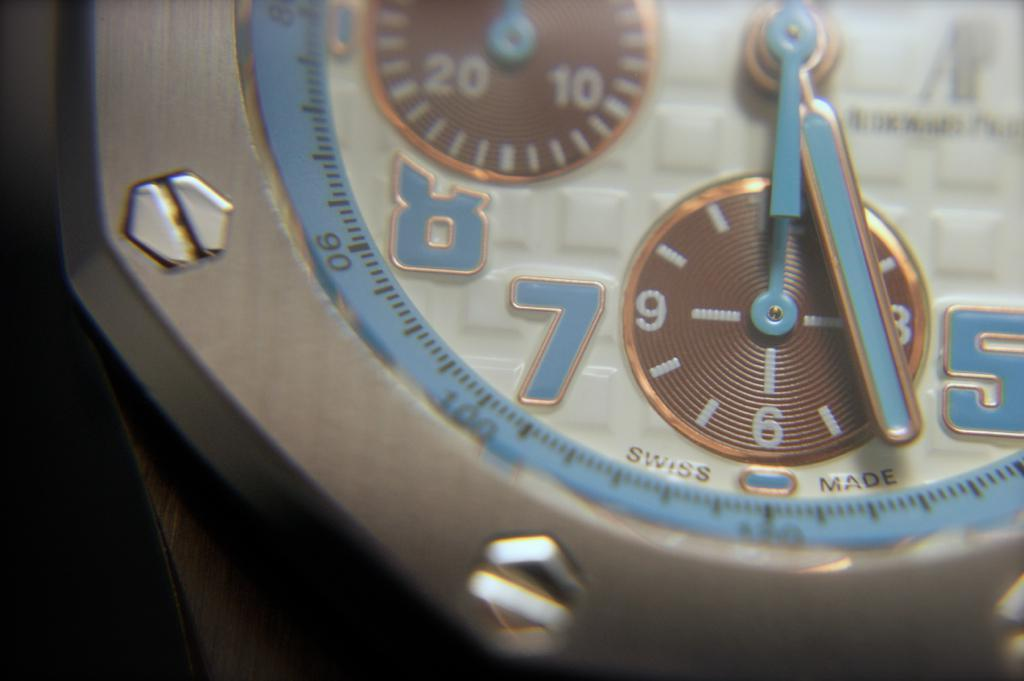What object is located in the front of the image? There is a watch in the front of the image. Can you describe the watch in more detail? Unfortunately, the provided facts do not offer any additional details about the watch. What might the presence of a watch in the image suggest? The presence of a watch in the image could suggest that time is a relevant factor or theme in the context of the image. What type of collar is visible on the watch in the image? There is no collar present on the watch in the image, as watches do not typically have collars. 